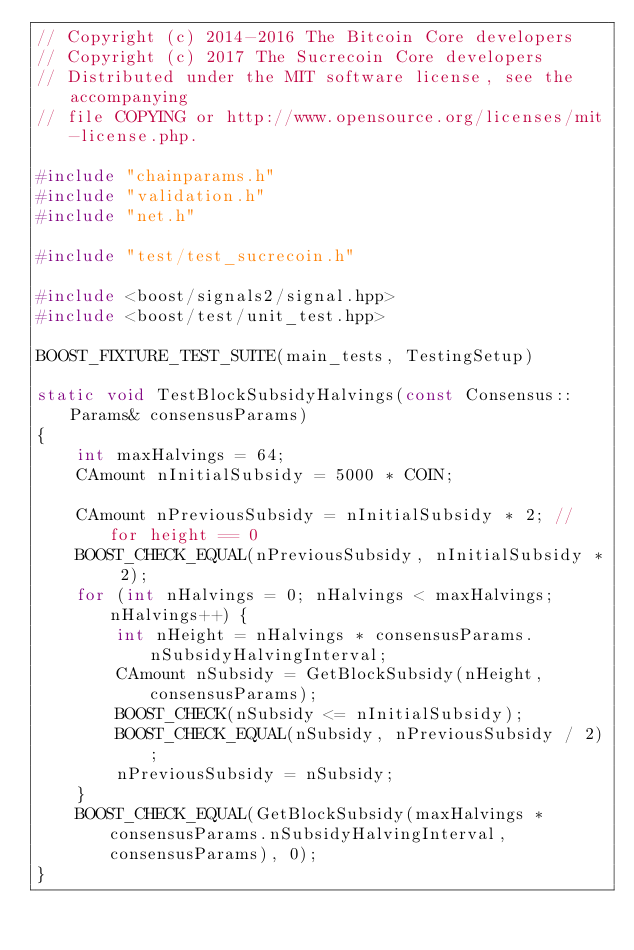<code> <loc_0><loc_0><loc_500><loc_500><_C++_>// Copyright (c) 2014-2016 The Bitcoin Core developers
// Copyright (c) 2017 The Sucrecoin Core developers
// Distributed under the MIT software license, see the accompanying
// file COPYING or http://www.opensource.org/licenses/mit-license.php.

#include "chainparams.h"
#include "validation.h"
#include "net.h"

#include "test/test_sucrecoin.h"

#include <boost/signals2/signal.hpp>
#include <boost/test/unit_test.hpp>

BOOST_FIXTURE_TEST_SUITE(main_tests, TestingSetup)

static void TestBlockSubsidyHalvings(const Consensus::Params& consensusParams)
{
    int maxHalvings = 64;
    CAmount nInitialSubsidy = 5000 * COIN;

    CAmount nPreviousSubsidy = nInitialSubsidy * 2; // for height == 0
    BOOST_CHECK_EQUAL(nPreviousSubsidy, nInitialSubsidy * 2);
    for (int nHalvings = 0; nHalvings < maxHalvings; nHalvings++) {
        int nHeight = nHalvings * consensusParams.nSubsidyHalvingInterval;
        CAmount nSubsidy = GetBlockSubsidy(nHeight, consensusParams);
        BOOST_CHECK(nSubsidy <= nInitialSubsidy);
        BOOST_CHECK_EQUAL(nSubsidy, nPreviousSubsidy / 2);
        nPreviousSubsidy = nSubsidy;
    }
    BOOST_CHECK_EQUAL(GetBlockSubsidy(maxHalvings * consensusParams.nSubsidyHalvingInterval, consensusParams), 0);
}
</code> 